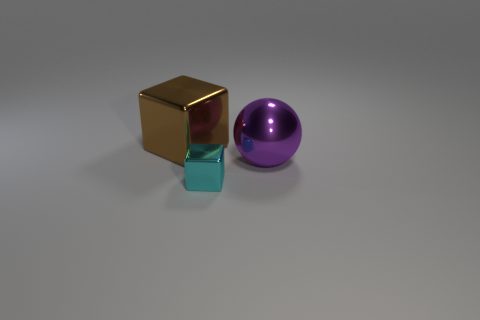Is there a small metallic thing that has the same color as the small metallic block?
Provide a short and direct response. No. Are there any other things that have the same size as the ball?
Your response must be concise. Yes. There is a metal ball; does it have the same color as the block in front of the sphere?
Offer a very short reply. No. What number of things are tiny purple metallic things or shiny objects behind the tiny cube?
Ensure brevity in your answer.  2. What size is the shiny object that is in front of the big shiny object in front of the brown metal thing?
Provide a succinct answer. Small. Are there an equal number of tiny blocks that are left of the cyan thing and tiny metallic cubes that are behind the large cube?
Ensure brevity in your answer.  Yes. Is there a cyan cube behind the big shiny thing that is to the right of the cyan metal block?
Your response must be concise. No. What shape is the small object that is made of the same material as the big brown thing?
Ensure brevity in your answer.  Cube. Is there anything else that is the same color as the large sphere?
Offer a terse response. No. What material is the big thing to the right of the shiny cube behind the large purple sphere?
Make the answer very short. Metal. 